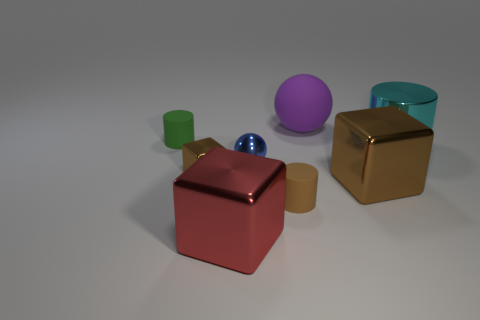Subtract all brown metal cubes. How many cubes are left? 1 Subtract all gray balls. How many brown cubes are left? 2 Subtract 1 cylinders. How many cylinders are left? 2 Add 2 cyan shiny objects. How many objects exist? 10 Subtract all cubes. How many objects are left? 5 Subtract all small purple metal spheres. Subtract all cyan objects. How many objects are left? 7 Add 3 green things. How many green things are left? 4 Add 4 small brown metal objects. How many small brown metal objects exist? 5 Subtract 0 purple cylinders. How many objects are left? 8 Subtract all red cubes. Subtract all brown cylinders. How many cubes are left? 2 